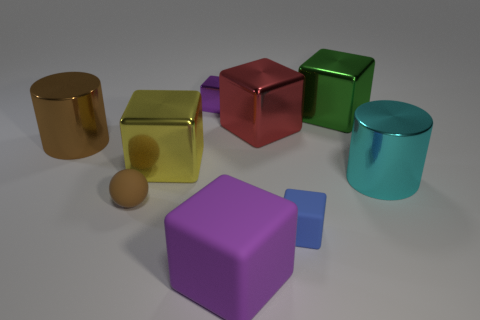Subtract all red cubes. How many cubes are left? 5 Add 1 green matte spheres. How many objects exist? 10 Subtract all cylinders. How many objects are left? 7 Subtract all purple cubes. How many cubes are left? 4 Add 9 cyan shiny cylinders. How many cyan shiny cylinders exist? 10 Subtract 0 purple spheres. How many objects are left? 9 Subtract 2 cylinders. How many cylinders are left? 0 Subtract all yellow cylinders. Subtract all yellow cubes. How many cylinders are left? 2 Subtract all gray balls. How many purple cubes are left? 2 Subtract all tiny blue things. Subtract all cyan shiny cylinders. How many objects are left? 7 